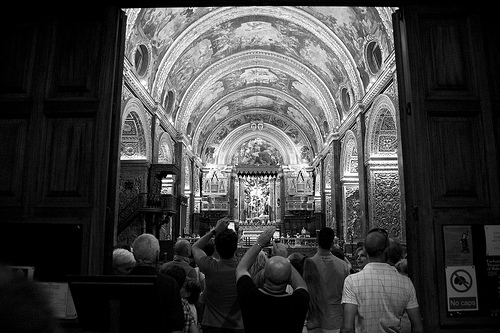Describe a detail from the image that might often be overlooked. An often overlooked detail in the image might be the intricate carvings and engravings on the wooden doors framing the entrance. These carvings could depict religious symbols, historical events, or local flora, each telling a part of the church's rich history and artistic heritage. 